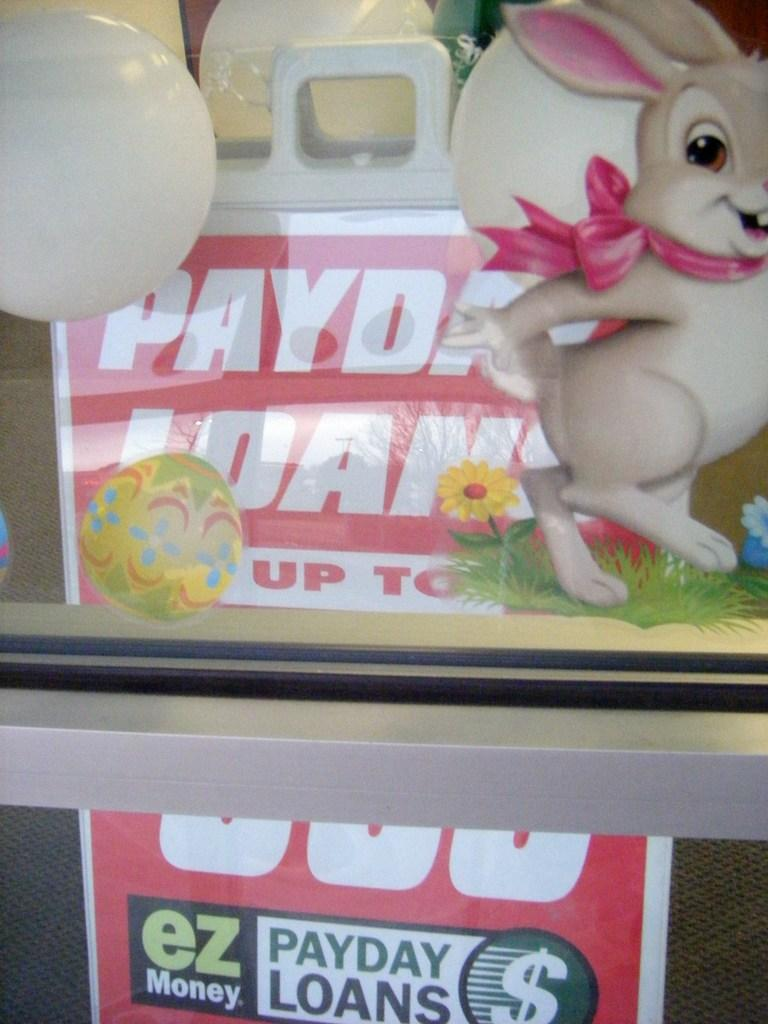<image>
Share a concise interpretation of the image provided. A sign for payday loans with a bunny in front of it. 